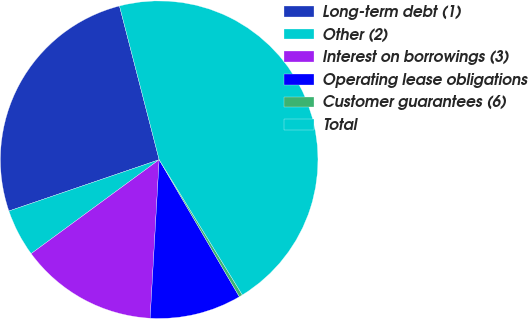<chart> <loc_0><loc_0><loc_500><loc_500><pie_chart><fcel>Long-term debt (1)<fcel>Other (2)<fcel>Interest on borrowings (3)<fcel>Operating lease obligations<fcel>Customer guarantees (6)<fcel>Total<nl><fcel>26.22%<fcel>4.84%<fcel>14.02%<fcel>9.33%<fcel>0.35%<fcel>45.25%<nl></chart> 